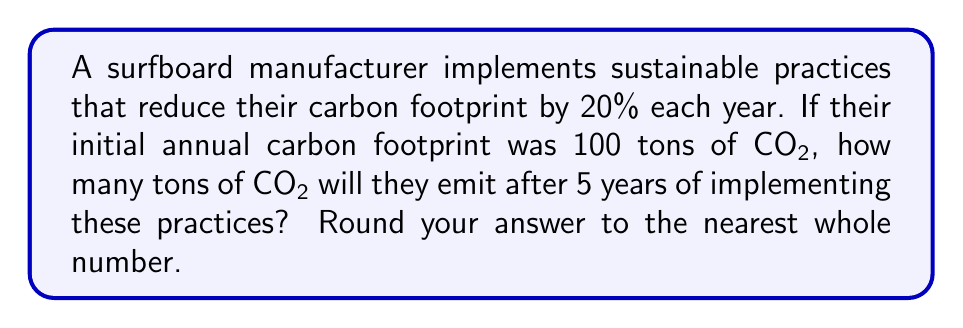Can you solve this math problem? Let's approach this step-by-step:

1) The initial carbon footprint is 100 tons of CO2.

2) Each year, the footprint is reduced by 20%, which means it becomes 80% of what it was the previous year.

3) We can represent this as an exponential function:
   $$C(t) = 100 \cdot (0.8)^t$$
   Where $C(t)$ is the carbon footprint after $t$ years.

4) We want to find $C(5)$, so let's substitute $t=5$:
   $$C(5) = 100 \cdot (0.8)^5$$

5) Now, let's calculate:
   $$C(5) = 100 \cdot 0.32768$$
   $$C(5) = 32.768$$

6) Rounding to the nearest whole number:
   $$C(5) \approx 33$$

Therefore, after 5 years, the manufacturer will emit approximately 33 tons of CO2.
Answer: 33 tons 